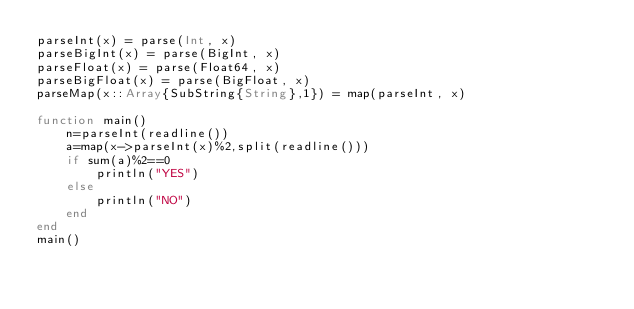Convert code to text. <code><loc_0><loc_0><loc_500><loc_500><_Julia_>parseInt(x) = parse(Int, x)
parseBigInt(x) = parse(BigInt, x)
parseFloat(x) = parse(Float64, x)
parseBigFloat(x) = parse(BigFloat, x)
parseMap(x::Array{SubString{String},1}) = map(parseInt, x)

function main()
    n=parseInt(readline())
    a=map(x->parseInt(x)%2,split(readline()))
    if sum(a)%2==0
        println("YES")
    else
        println("NO")
    end
end
main()</code> 